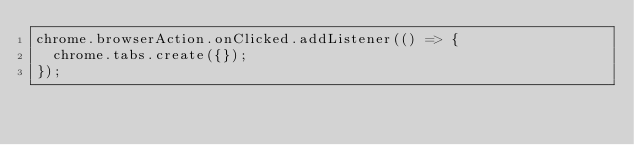<code> <loc_0><loc_0><loc_500><loc_500><_JavaScript_>chrome.browserAction.onClicked.addListener(() => {
  chrome.tabs.create({});
});
</code> 